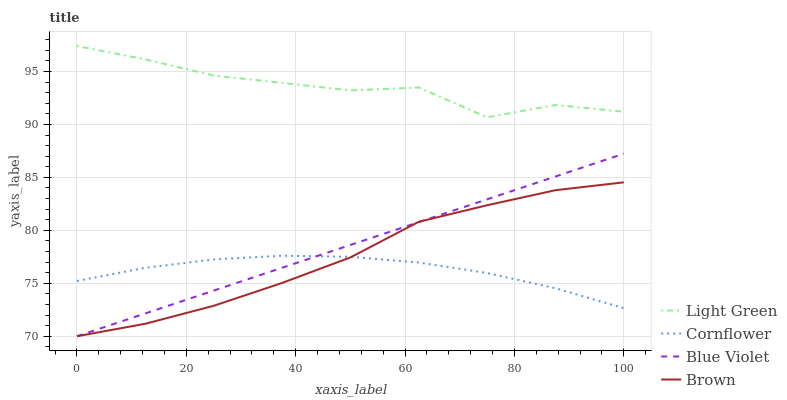Does Cornflower have the minimum area under the curve?
Answer yes or no. Yes. Does Light Green have the maximum area under the curve?
Answer yes or no. Yes. Does Blue Violet have the minimum area under the curve?
Answer yes or no. No. Does Blue Violet have the maximum area under the curve?
Answer yes or no. No. Is Blue Violet the smoothest?
Answer yes or no. Yes. Is Light Green the roughest?
Answer yes or no. Yes. Is Light Green the smoothest?
Answer yes or no. No. Is Blue Violet the roughest?
Answer yes or no. No. Does Blue Violet have the lowest value?
Answer yes or no. Yes. Does Light Green have the lowest value?
Answer yes or no. No. Does Light Green have the highest value?
Answer yes or no. Yes. Does Blue Violet have the highest value?
Answer yes or no. No. Is Brown less than Light Green?
Answer yes or no. Yes. Is Light Green greater than Brown?
Answer yes or no. Yes. Does Blue Violet intersect Brown?
Answer yes or no. Yes. Is Blue Violet less than Brown?
Answer yes or no. No. Is Blue Violet greater than Brown?
Answer yes or no. No. Does Brown intersect Light Green?
Answer yes or no. No. 